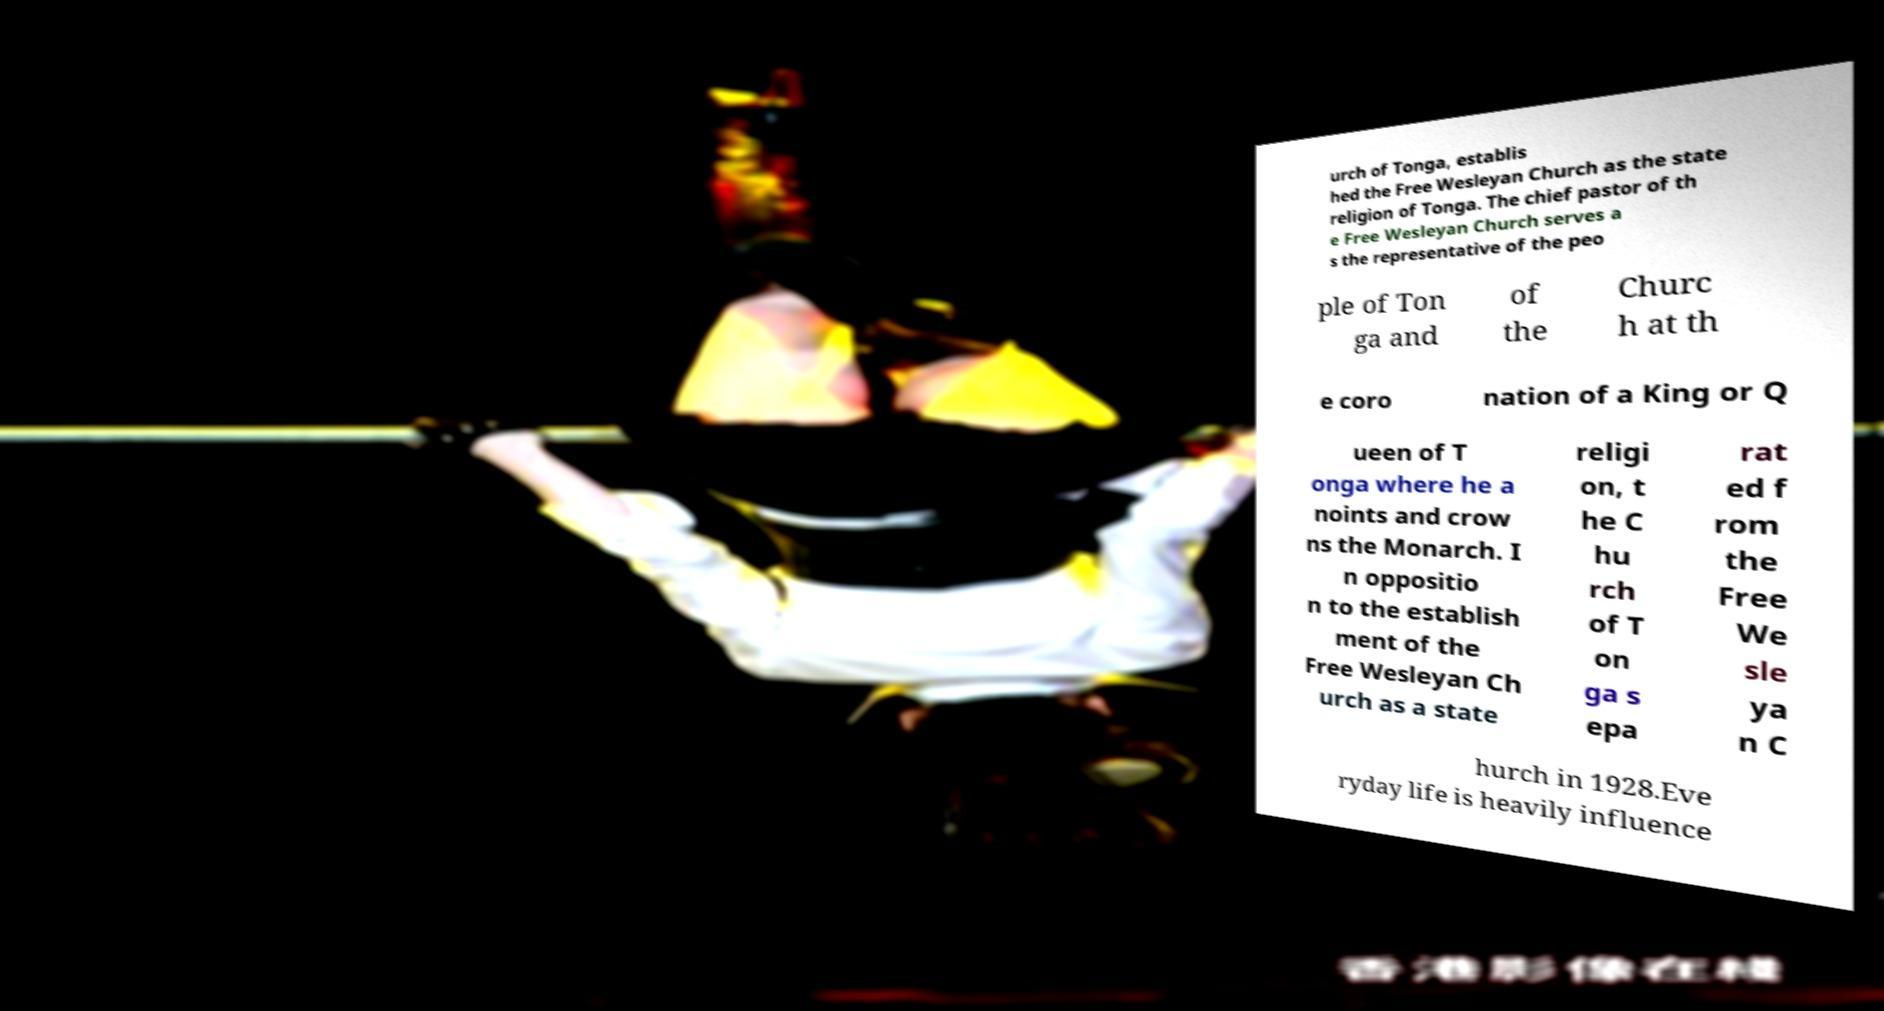There's text embedded in this image that I need extracted. Can you transcribe it verbatim? urch of Tonga, establis hed the Free Wesleyan Church as the state religion of Tonga. The chief pastor of th e Free Wesleyan Church serves a s the representative of the peo ple of Ton ga and of the Churc h at th e coro nation of a King or Q ueen of T onga where he a noints and crow ns the Monarch. I n oppositio n to the establish ment of the Free Wesleyan Ch urch as a state religi on, t he C hu rch of T on ga s epa rat ed f rom the Free We sle ya n C hurch in 1928.Eve ryday life is heavily influence 